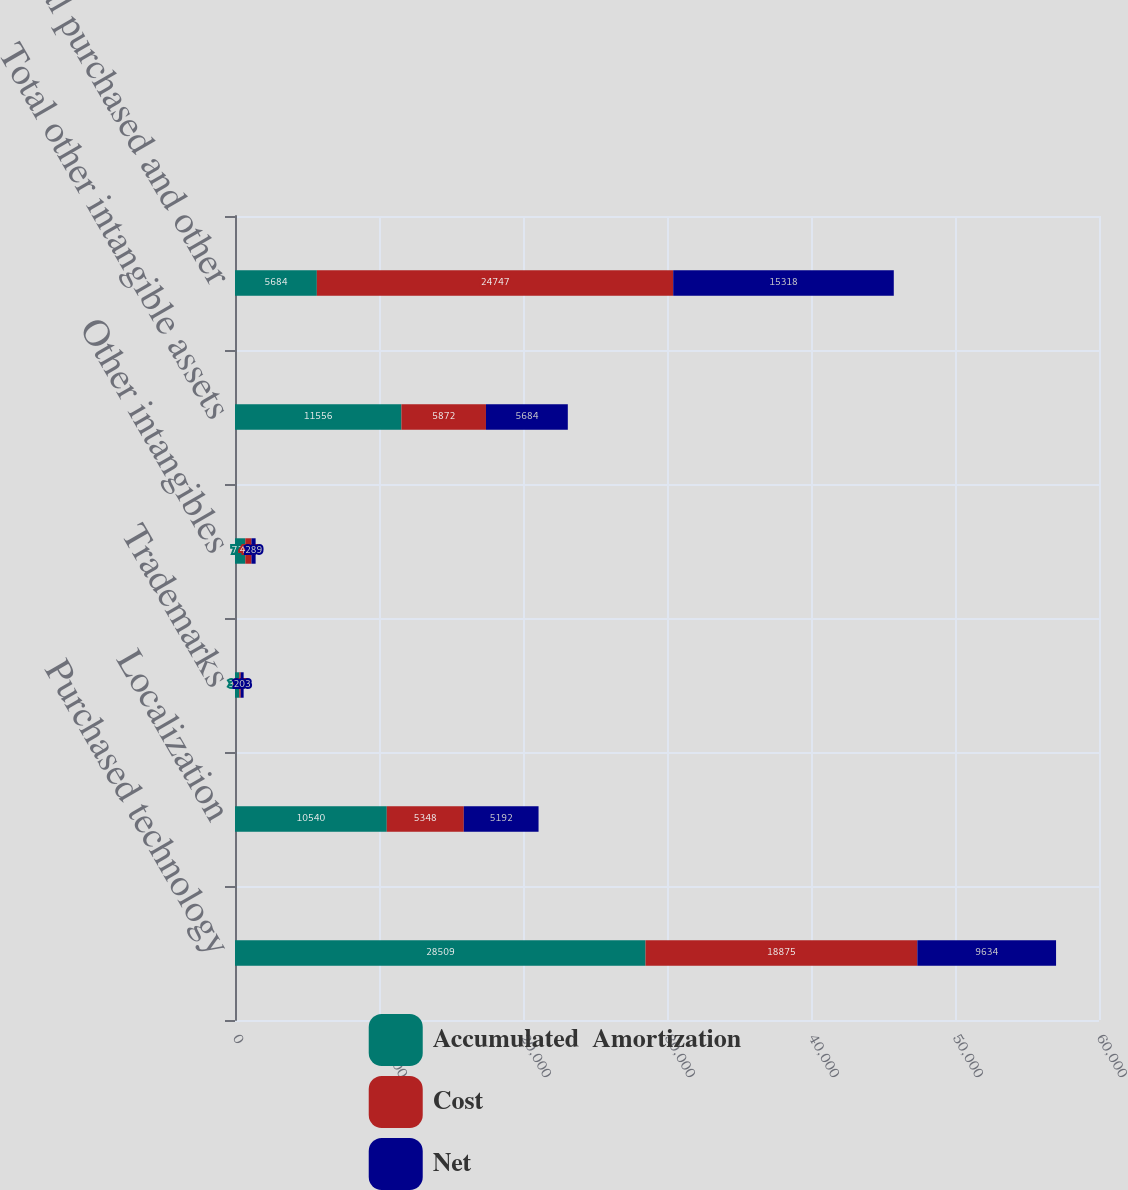<chart> <loc_0><loc_0><loc_500><loc_500><stacked_bar_chart><ecel><fcel>Purchased technology<fcel>Localization<fcel>Trademarks<fcel>Other intangibles<fcel>Total other intangible assets<fcel>Total purchased and other<nl><fcel>Accumulated  Amortization<fcel>28509<fcel>10540<fcel>300<fcel>716<fcel>11556<fcel>5684<nl><fcel>Cost<fcel>18875<fcel>5348<fcel>97<fcel>427<fcel>5872<fcel>24747<nl><fcel>Net<fcel>9634<fcel>5192<fcel>203<fcel>289<fcel>5684<fcel>15318<nl></chart> 